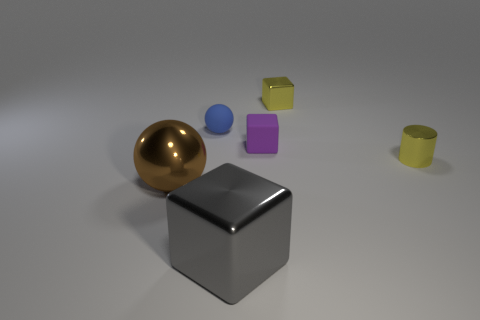What material is the large thing that is behind the metal object in front of the large metallic object that is behind the large gray cube?
Offer a very short reply. Metal. There is a sphere that is on the right side of the brown object; is it the same size as the metallic cube behind the purple cube?
Ensure brevity in your answer.  Yes. How many other things are the same material as the yellow cylinder?
Provide a succinct answer. 3. What number of shiny things are brown spheres or cylinders?
Offer a terse response. 2. Are there fewer tiny yellow metallic cylinders than small green shiny cylinders?
Your answer should be very brief. No. Is the size of the brown object the same as the metal cube in front of the big brown thing?
Make the answer very short. Yes. Is there any other thing that is the same shape as the brown object?
Provide a succinct answer. Yes. What size is the yellow cylinder?
Provide a short and direct response. Small. Is the number of matte balls behind the yellow shiny cylinder less than the number of shiny blocks?
Offer a terse response. Yes. Does the gray shiny object have the same size as the purple block?
Your answer should be compact. No. 